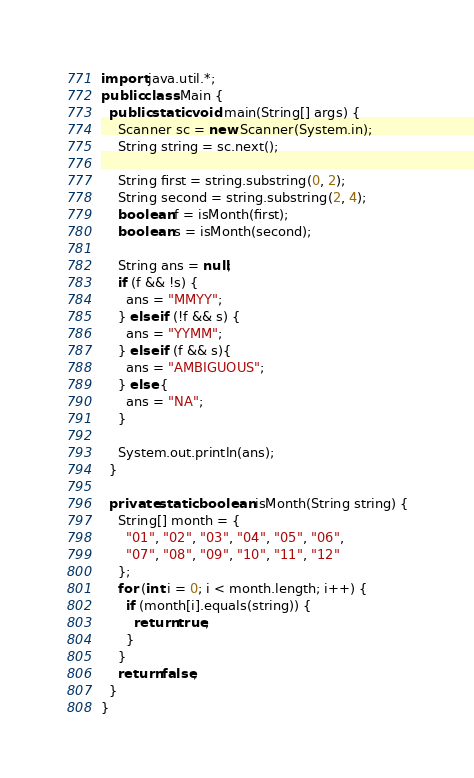<code> <loc_0><loc_0><loc_500><loc_500><_Java_>import java.util.*;
public class Main {
  public static void main(String[] args) {
    Scanner sc = new Scanner(System.in);
    String string = sc.next();

    String first = string.substring(0, 2);
    String second = string.substring(2, 4);
    boolean f = isMonth(first);
    boolean s = isMonth(second);
    
    String ans = null;
    if (f && !s) {
      ans = "MMYY";
    } else if (!f && s) {
      ans = "YYMM";
    } else if (f && s){
      ans = "AMBIGUOUS";
    } else {
      ans = "NA";
    }
    
    System.out.println(ans);
  }
  
  private static boolean isMonth(String string) {
    String[] month = {
      "01", "02", "03", "04", "05", "06", 
      "07", "08", "09", "10", "11", "12"
    };
    for (int i = 0; i < month.length; i++) {
      if (month[i].equals(string)) {
        return true;
      }
    }
    return false;
  }
}</code> 